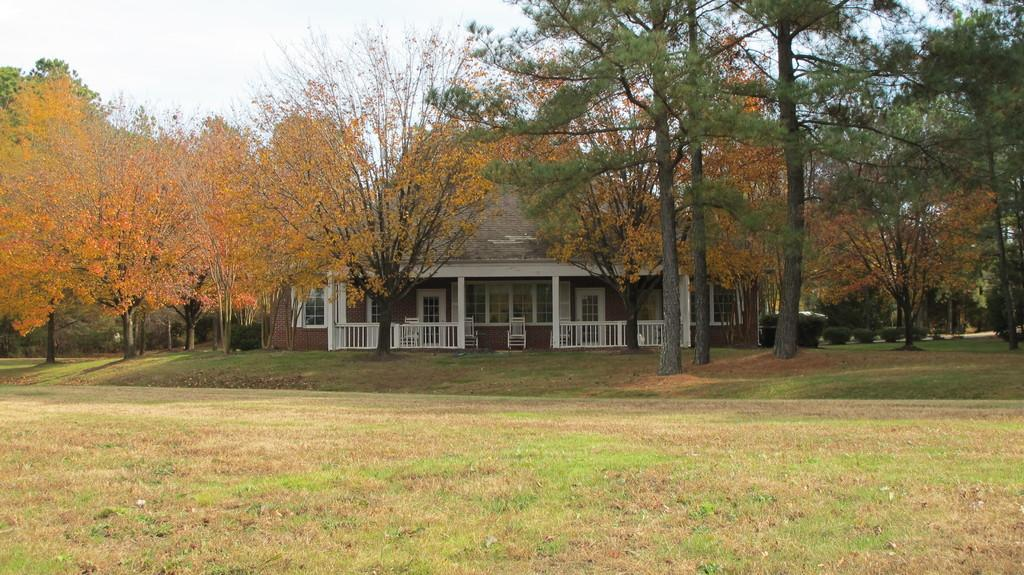What type of structure is visible in the image? There is a house in the image. What features can be seen on the house? The house has doors and windows. What type of furniture is present in the image? There are chairs in the image. What type of vegetation can be seen in the image? There are trees, plants, and grass in the image. What is visible at the top of the image? The sky is visible at the top of the image. What type of prison can be seen in the image? There is no prison present in the image; it features a house with doors and windows. What type of ray is emitted from the house in the image? There is no mention of a ray in the image; it features a house with doors and windows. 